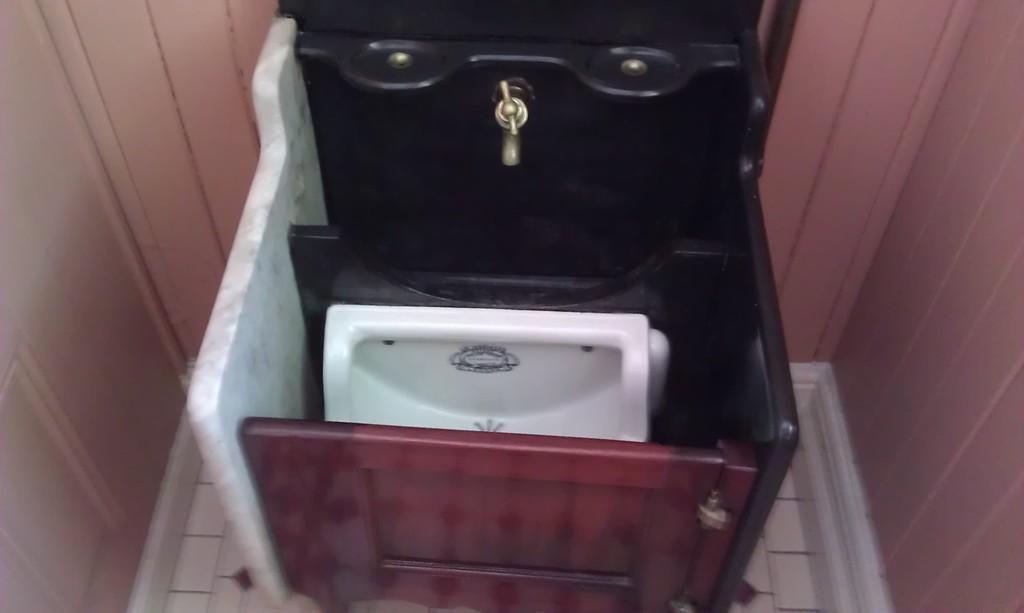Could you give a brief overview of what you see in this image? In this picture I can see white color toilet seat, a tap, wooden object and other objects. 